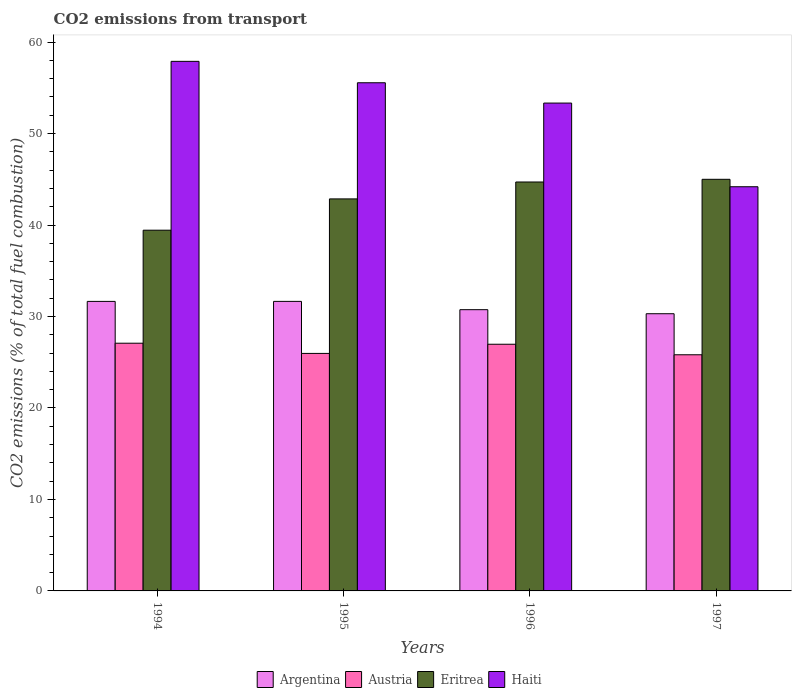Are the number of bars per tick equal to the number of legend labels?
Provide a succinct answer. Yes. Are the number of bars on each tick of the X-axis equal?
Keep it short and to the point. Yes. In how many cases, is the number of bars for a given year not equal to the number of legend labels?
Your answer should be very brief. 0. What is the total CO2 emitted in Haiti in 1997?
Give a very brief answer. 44.19. Across all years, what is the maximum total CO2 emitted in Argentina?
Your answer should be compact. 31.65. Across all years, what is the minimum total CO2 emitted in Argentina?
Make the answer very short. 30.3. In which year was the total CO2 emitted in Haiti maximum?
Offer a terse response. 1994. What is the total total CO2 emitted in Austria in the graph?
Offer a terse response. 105.83. What is the difference between the total CO2 emitted in Eritrea in 1994 and that in 1995?
Provide a short and direct response. -3.42. What is the difference between the total CO2 emitted in Argentina in 1994 and the total CO2 emitted in Eritrea in 1995?
Provide a succinct answer. -11.2. What is the average total CO2 emitted in Eritrea per year?
Offer a terse response. 43. In the year 1996, what is the difference between the total CO2 emitted in Austria and total CO2 emitted in Eritrea?
Your answer should be very brief. -17.74. In how many years, is the total CO2 emitted in Austria greater than 26?
Provide a short and direct response. 2. What is the ratio of the total CO2 emitted in Argentina in 1996 to that in 1997?
Keep it short and to the point. 1.01. Is the difference between the total CO2 emitted in Austria in 1995 and 1997 greater than the difference between the total CO2 emitted in Eritrea in 1995 and 1997?
Provide a short and direct response. Yes. What is the difference between the highest and the second highest total CO2 emitted in Haiti?
Your answer should be very brief. 2.34. What is the difference between the highest and the lowest total CO2 emitted in Austria?
Offer a terse response. 1.26. Is the sum of the total CO2 emitted in Haiti in 1994 and 1995 greater than the maximum total CO2 emitted in Eritrea across all years?
Ensure brevity in your answer.  Yes. What does the 2nd bar from the left in 1995 represents?
Your answer should be compact. Austria. How many bars are there?
Your response must be concise. 16. Are all the bars in the graph horizontal?
Keep it short and to the point. No. How many years are there in the graph?
Offer a terse response. 4. Does the graph contain any zero values?
Provide a succinct answer. No. Does the graph contain grids?
Offer a very short reply. No. Where does the legend appear in the graph?
Provide a short and direct response. Bottom center. How many legend labels are there?
Ensure brevity in your answer.  4. What is the title of the graph?
Your answer should be compact. CO2 emissions from transport. Does "Samoa" appear as one of the legend labels in the graph?
Keep it short and to the point. No. What is the label or title of the Y-axis?
Provide a short and direct response. CO2 emissions (% of total fuel combustion). What is the CO2 emissions (% of total fuel combustion) in Argentina in 1994?
Ensure brevity in your answer.  31.65. What is the CO2 emissions (% of total fuel combustion) of Austria in 1994?
Your answer should be very brief. 27.08. What is the CO2 emissions (% of total fuel combustion) in Eritrea in 1994?
Your response must be concise. 39.44. What is the CO2 emissions (% of total fuel combustion) in Haiti in 1994?
Your response must be concise. 57.89. What is the CO2 emissions (% of total fuel combustion) of Argentina in 1995?
Your answer should be compact. 31.65. What is the CO2 emissions (% of total fuel combustion) in Austria in 1995?
Your response must be concise. 25.96. What is the CO2 emissions (% of total fuel combustion) of Eritrea in 1995?
Make the answer very short. 42.86. What is the CO2 emissions (% of total fuel combustion) in Haiti in 1995?
Give a very brief answer. 55.56. What is the CO2 emissions (% of total fuel combustion) of Argentina in 1996?
Keep it short and to the point. 30.75. What is the CO2 emissions (% of total fuel combustion) in Austria in 1996?
Give a very brief answer. 26.97. What is the CO2 emissions (% of total fuel combustion) of Eritrea in 1996?
Your answer should be very brief. 44.71. What is the CO2 emissions (% of total fuel combustion) in Haiti in 1996?
Provide a succinct answer. 53.33. What is the CO2 emissions (% of total fuel combustion) of Argentina in 1997?
Keep it short and to the point. 30.3. What is the CO2 emissions (% of total fuel combustion) of Austria in 1997?
Make the answer very short. 25.82. What is the CO2 emissions (% of total fuel combustion) in Eritrea in 1997?
Provide a short and direct response. 45. What is the CO2 emissions (% of total fuel combustion) of Haiti in 1997?
Your response must be concise. 44.19. Across all years, what is the maximum CO2 emissions (% of total fuel combustion) in Argentina?
Offer a terse response. 31.65. Across all years, what is the maximum CO2 emissions (% of total fuel combustion) in Austria?
Make the answer very short. 27.08. Across all years, what is the maximum CO2 emissions (% of total fuel combustion) in Haiti?
Give a very brief answer. 57.89. Across all years, what is the minimum CO2 emissions (% of total fuel combustion) in Argentina?
Give a very brief answer. 30.3. Across all years, what is the minimum CO2 emissions (% of total fuel combustion) in Austria?
Make the answer very short. 25.82. Across all years, what is the minimum CO2 emissions (% of total fuel combustion) in Eritrea?
Ensure brevity in your answer.  39.44. Across all years, what is the minimum CO2 emissions (% of total fuel combustion) in Haiti?
Offer a terse response. 44.19. What is the total CO2 emissions (% of total fuel combustion) in Argentina in the graph?
Provide a succinct answer. 124.36. What is the total CO2 emissions (% of total fuel combustion) in Austria in the graph?
Make the answer very short. 105.83. What is the total CO2 emissions (% of total fuel combustion) in Eritrea in the graph?
Keep it short and to the point. 172. What is the total CO2 emissions (% of total fuel combustion) of Haiti in the graph?
Your answer should be very brief. 210.97. What is the difference between the CO2 emissions (% of total fuel combustion) in Argentina in 1994 and that in 1995?
Offer a very short reply. -0. What is the difference between the CO2 emissions (% of total fuel combustion) in Austria in 1994 and that in 1995?
Your answer should be compact. 1.12. What is the difference between the CO2 emissions (% of total fuel combustion) of Eritrea in 1994 and that in 1995?
Offer a very short reply. -3.42. What is the difference between the CO2 emissions (% of total fuel combustion) of Haiti in 1994 and that in 1995?
Make the answer very short. 2.34. What is the difference between the CO2 emissions (% of total fuel combustion) of Argentina in 1994 and that in 1996?
Your answer should be compact. 0.91. What is the difference between the CO2 emissions (% of total fuel combustion) in Austria in 1994 and that in 1996?
Ensure brevity in your answer.  0.11. What is the difference between the CO2 emissions (% of total fuel combustion) in Eritrea in 1994 and that in 1996?
Keep it short and to the point. -5.27. What is the difference between the CO2 emissions (% of total fuel combustion) of Haiti in 1994 and that in 1996?
Your response must be concise. 4.56. What is the difference between the CO2 emissions (% of total fuel combustion) in Argentina in 1994 and that in 1997?
Your answer should be compact. 1.35. What is the difference between the CO2 emissions (% of total fuel combustion) of Austria in 1994 and that in 1997?
Keep it short and to the point. 1.26. What is the difference between the CO2 emissions (% of total fuel combustion) of Eritrea in 1994 and that in 1997?
Make the answer very short. -5.56. What is the difference between the CO2 emissions (% of total fuel combustion) in Haiti in 1994 and that in 1997?
Your answer should be compact. 13.71. What is the difference between the CO2 emissions (% of total fuel combustion) of Argentina in 1995 and that in 1996?
Give a very brief answer. 0.91. What is the difference between the CO2 emissions (% of total fuel combustion) in Austria in 1995 and that in 1996?
Provide a short and direct response. -1. What is the difference between the CO2 emissions (% of total fuel combustion) of Eritrea in 1995 and that in 1996?
Your answer should be compact. -1.85. What is the difference between the CO2 emissions (% of total fuel combustion) in Haiti in 1995 and that in 1996?
Ensure brevity in your answer.  2.22. What is the difference between the CO2 emissions (% of total fuel combustion) of Argentina in 1995 and that in 1997?
Your response must be concise. 1.35. What is the difference between the CO2 emissions (% of total fuel combustion) in Austria in 1995 and that in 1997?
Your answer should be compact. 0.15. What is the difference between the CO2 emissions (% of total fuel combustion) in Eritrea in 1995 and that in 1997?
Give a very brief answer. -2.14. What is the difference between the CO2 emissions (% of total fuel combustion) in Haiti in 1995 and that in 1997?
Your answer should be compact. 11.37. What is the difference between the CO2 emissions (% of total fuel combustion) of Argentina in 1996 and that in 1997?
Give a very brief answer. 0.44. What is the difference between the CO2 emissions (% of total fuel combustion) of Austria in 1996 and that in 1997?
Offer a very short reply. 1.15. What is the difference between the CO2 emissions (% of total fuel combustion) of Eritrea in 1996 and that in 1997?
Your answer should be compact. -0.29. What is the difference between the CO2 emissions (% of total fuel combustion) of Haiti in 1996 and that in 1997?
Offer a terse response. 9.15. What is the difference between the CO2 emissions (% of total fuel combustion) in Argentina in 1994 and the CO2 emissions (% of total fuel combustion) in Austria in 1995?
Ensure brevity in your answer.  5.69. What is the difference between the CO2 emissions (% of total fuel combustion) of Argentina in 1994 and the CO2 emissions (% of total fuel combustion) of Eritrea in 1995?
Provide a succinct answer. -11.2. What is the difference between the CO2 emissions (% of total fuel combustion) of Argentina in 1994 and the CO2 emissions (% of total fuel combustion) of Haiti in 1995?
Your response must be concise. -23.9. What is the difference between the CO2 emissions (% of total fuel combustion) in Austria in 1994 and the CO2 emissions (% of total fuel combustion) in Eritrea in 1995?
Offer a terse response. -15.78. What is the difference between the CO2 emissions (% of total fuel combustion) in Austria in 1994 and the CO2 emissions (% of total fuel combustion) in Haiti in 1995?
Your response must be concise. -28.48. What is the difference between the CO2 emissions (% of total fuel combustion) in Eritrea in 1994 and the CO2 emissions (% of total fuel combustion) in Haiti in 1995?
Offer a very short reply. -16.12. What is the difference between the CO2 emissions (% of total fuel combustion) of Argentina in 1994 and the CO2 emissions (% of total fuel combustion) of Austria in 1996?
Keep it short and to the point. 4.68. What is the difference between the CO2 emissions (% of total fuel combustion) of Argentina in 1994 and the CO2 emissions (% of total fuel combustion) of Eritrea in 1996?
Your response must be concise. -13.05. What is the difference between the CO2 emissions (% of total fuel combustion) of Argentina in 1994 and the CO2 emissions (% of total fuel combustion) of Haiti in 1996?
Ensure brevity in your answer.  -21.68. What is the difference between the CO2 emissions (% of total fuel combustion) in Austria in 1994 and the CO2 emissions (% of total fuel combustion) in Eritrea in 1996?
Your answer should be compact. -17.63. What is the difference between the CO2 emissions (% of total fuel combustion) of Austria in 1994 and the CO2 emissions (% of total fuel combustion) of Haiti in 1996?
Make the answer very short. -26.25. What is the difference between the CO2 emissions (% of total fuel combustion) in Eritrea in 1994 and the CO2 emissions (% of total fuel combustion) in Haiti in 1996?
Your answer should be compact. -13.9. What is the difference between the CO2 emissions (% of total fuel combustion) in Argentina in 1994 and the CO2 emissions (% of total fuel combustion) in Austria in 1997?
Make the answer very short. 5.83. What is the difference between the CO2 emissions (% of total fuel combustion) in Argentina in 1994 and the CO2 emissions (% of total fuel combustion) in Eritrea in 1997?
Offer a terse response. -13.35. What is the difference between the CO2 emissions (% of total fuel combustion) of Argentina in 1994 and the CO2 emissions (% of total fuel combustion) of Haiti in 1997?
Make the answer very short. -12.53. What is the difference between the CO2 emissions (% of total fuel combustion) of Austria in 1994 and the CO2 emissions (% of total fuel combustion) of Eritrea in 1997?
Make the answer very short. -17.92. What is the difference between the CO2 emissions (% of total fuel combustion) of Austria in 1994 and the CO2 emissions (% of total fuel combustion) of Haiti in 1997?
Make the answer very short. -17.11. What is the difference between the CO2 emissions (% of total fuel combustion) of Eritrea in 1994 and the CO2 emissions (% of total fuel combustion) of Haiti in 1997?
Your response must be concise. -4.75. What is the difference between the CO2 emissions (% of total fuel combustion) in Argentina in 1995 and the CO2 emissions (% of total fuel combustion) in Austria in 1996?
Ensure brevity in your answer.  4.68. What is the difference between the CO2 emissions (% of total fuel combustion) of Argentina in 1995 and the CO2 emissions (% of total fuel combustion) of Eritrea in 1996?
Provide a short and direct response. -13.05. What is the difference between the CO2 emissions (% of total fuel combustion) in Argentina in 1995 and the CO2 emissions (% of total fuel combustion) in Haiti in 1996?
Your response must be concise. -21.68. What is the difference between the CO2 emissions (% of total fuel combustion) in Austria in 1995 and the CO2 emissions (% of total fuel combustion) in Eritrea in 1996?
Your answer should be compact. -18.74. What is the difference between the CO2 emissions (% of total fuel combustion) of Austria in 1995 and the CO2 emissions (% of total fuel combustion) of Haiti in 1996?
Your response must be concise. -27.37. What is the difference between the CO2 emissions (% of total fuel combustion) of Eritrea in 1995 and the CO2 emissions (% of total fuel combustion) of Haiti in 1996?
Offer a very short reply. -10.48. What is the difference between the CO2 emissions (% of total fuel combustion) of Argentina in 1995 and the CO2 emissions (% of total fuel combustion) of Austria in 1997?
Your answer should be very brief. 5.84. What is the difference between the CO2 emissions (% of total fuel combustion) of Argentina in 1995 and the CO2 emissions (% of total fuel combustion) of Eritrea in 1997?
Your response must be concise. -13.35. What is the difference between the CO2 emissions (% of total fuel combustion) of Argentina in 1995 and the CO2 emissions (% of total fuel combustion) of Haiti in 1997?
Ensure brevity in your answer.  -12.53. What is the difference between the CO2 emissions (% of total fuel combustion) in Austria in 1995 and the CO2 emissions (% of total fuel combustion) in Eritrea in 1997?
Provide a succinct answer. -19.04. What is the difference between the CO2 emissions (% of total fuel combustion) in Austria in 1995 and the CO2 emissions (% of total fuel combustion) in Haiti in 1997?
Provide a short and direct response. -18.22. What is the difference between the CO2 emissions (% of total fuel combustion) of Eritrea in 1995 and the CO2 emissions (% of total fuel combustion) of Haiti in 1997?
Provide a succinct answer. -1.33. What is the difference between the CO2 emissions (% of total fuel combustion) in Argentina in 1996 and the CO2 emissions (% of total fuel combustion) in Austria in 1997?
Keep it short and to the point. 4.93. What is the difference between the CO2 emissions (% of total fuel combustion) in Argentina in 1996 and the CO2 emissions (% of total fuel combustion) in Eritrea in 1997?
Make the answer very short. -14.25. What is the difference between the CO2 emissions (% of total fuel combustion) in Argentina in 1996 and the CO2 emissions (% of total fuel combustion) in Haiti in 1997?
Offer a very short reply. -13.44. What is the difference between the CO2 emissions (% of total fuel combustion) of Austria in 1996 and the CO2 emissions (% of total fuel combustion) of Eritrea in 1997?
Provide a short and direct response. -18.03. What is the difference between the CO2 emissions (% of total fuel combustion) in Austria in 1996 and the CO2 emissions (% of total fuel combustion) in Haiti in 1997?
Ensure brevity in your answer.  -17.22. What is the difference between the CO2 emissions (% of total fuel combustion) of Eritrea in 1996 and the CO2 emissions (% of total fuel combustion) of Haiti in 1997?
Make the answer very short. 0.52. What is the average CO2 emissions (% of total fuel combustion) in Argentina per year?
Your answer should be compact. 31.09. What is the average CO2 emissions (% of total fuel combustion) of Austria per year?
Your response must be concise. 26.46. What is the average CO2 emissions (% of total fuel combustion) in Eritrea per year?
Give a very brief answer. 43. What is the average CO2 emissions (% of total fuel combustion) of Haiti per year?
Make the answer very short. 52.74. In the year 1994, what is the difference between the CO2 emissions (% of total fuel combustion) of Argentina and CO2 emissions (% of total fuel combustion) of Austria?
Your response must be concise. 4.57. In the year 1994, what is the difference between the CO2 emissions (% of total fuel combustion) of Argentina and CO2 emissions (% of total fuel combustion) of Eritrea?
Provide a succinct answer. -7.78. In the year 1994, what is the difference between the CO2 emissions (% of total fuel combustion) of Argentina and CO2 emissions (% of total fuel combustion) of Haiti?
Your answer should be very brief. -26.24. In the year 1994, what is the difference between the CO2 emissions (% of total fuel combustion) in Austria and CO2 emissions (% of total fuel combustion) in Eritrea?
Make the answer very short. -12.36. In the year 1994, what is the difference between the CO2 emissions (% of total fuel combustion) of Austria and CO2 emissions (% of total fuel combustion) of Haiti?
Your answer should be compact. -30.81. In the year 1994, what is the difference between the CO2 emissions (% of total fuel combustion) in Eritrea and CO2 emissions (% of total fuel combustion) in Haiti?
Your response must be concise. -18.46. In the year 1995, what is the difference between the CO2 emissions (% of total fuel combustion) of Argentina and CO2 emissions (% of total fuel combustion) of Austria?
Provide a succinct answer. 5.69. In the year 1995, what is the difference between the CO2 emissions (% of total fuel combustion) of Argentina and CO2 emissions (% of total fuel combustion) of Eritrea?
Keep it short and to the point. -11.2. In the year 1995, what is the difference between the CO2 emissions (% of total fuel combustion) of Argentina and CO2 emissions (% of total fuel combustion) of Haiti?
Provide a succinct answer. -23.9. In the year 1995, what is the difference between the CO2 emissions (% of total fuel combustion) of Austria and CO2 emissions (% of total fuel combustion) of Eritrea?
Make the answer very short. -16.89. In the year 1995, what is the difference between the CO2 emissions (% of total fuel combustion) in Austria and CO2 emissions (% of total fuel combustion) in Haiti?
Make the answer very short. -29.59. In the year 1995, what is the difference between the CO2 emissions (% of total fuel combustion) of Eritrea and CO2 emissions (% of total fuel combustion) of Haiti?
Your answer should be very brief. -12.7. In the year 1996, what is the difference between the CO2 emissions (% of total fuel combustion) in Argentina and CO2 emissions (% of total fuel combustion) in Austria?
Offer a terse response. 3.78. In the year 1996, what is the difference between the CO2 emissions (% of total fuel combustion) of Argentina and CO2 emissions (% of total fuel combustion) of Eritrea?
Your answer should be compact. -13.96. In the year 1996, what is the difference between the CO2 emissions (% of total fuel combustion) in Argentina and CO2 emissions (% of total fuel combustion) in Haiti?
Keep it short and to the point. -22.59. In the year 1996, what is the difference between the CO2 emissions (% of total fuel combustion) in Austria and CO2 emissions (% of total fuel combustion) in Eritrea?
Offer a terse response. -17.74. In the year 1996, what is the difference between the CO2 emissions (% of total fuel combustion) in Austria and CO2 emissions (% of total fuel combustion) in Haiti?
Make the answer very short. -26.36. In the year 1996, what is the difference between the CO2 emissions (% of total fuel combustion) in Eritrea and CO2 emissions (% of total fuel combustion) in Haiti?
Ensure brevity in your answer.  -8.63. In the year 1997, what is the difference between the CO2 emissions (% of total fuel combustion) of Argentina and CO2 emissions (% of total fuel combustion) of Austria?
Offer a very short reply. 4.49. In the year 1997, what is the difference between the CO2 emissions (% of total fuel combustion) in Argentina and CO2 emissions (% of total fuel combustion) in Eritrea?
Provide a short and direct response. -14.7. In the year 1997, what is the difference between the CO2 emissions (% of total fuel combustion) of Argentina and CO2 emissions (% of total fuel combustion) of Haiti?
Offer a very short reply. -13.88. In the year 1997, what is the difference between the CO2 emissions (% of total fuel combustion) of Austria and CO2 emissions (% of total fuel combustion) of Eritrea?
Your answer should be very brief. -19.18. In the year 1997, what is the difference between the CO2 emissions (% of total fuel combustion) of Austria and CO2 emissions (% of total fuel combustion) of Haiti?
Provide a short and direct response. -18.37. In the year 1997, what is the difference between the CO2 emissions (% of total fuel combustion) in Eritrea and CO2 emissions (% of total fuel combustion) in Haiti?
Make the answer very short. 0.81. What is the ratio of the CO2 emissions (% of total fuel combustion) of Austria in 1994 to that in 1995?
Keep it short and to the point. 1.04. What is the ratio of the CO2 emissions (% of total fuel combustion) in Eritrea in 1994 to that in 1995?
Offer a very short reply. 0.92. What is the ratio of the CO2 emissions (% of total fuel combustion) of Haiti in 1994 to that in 1995?
Your answer should be very brief. 1.04. What is the ratio of the CO2 emissions (% of total fuel combustion) in Argentina in 1994 to that in 1996?
Provide a short and direct response. 1.03. What is the ratio of the CO2 emissions (% of total fuel combustion) of Eritrea in 1994 to that in 1996?
Offer a terse response. 0.88. What is the ratio of the CO2 emissions (% of total fuel combustion) in Haiti in 1994 to that in 1996?
Give a very brief answer. 1.09. What is the ratio of the CO2 emissions (% of total fuel combustion) of Argentina in 1994 to that in 1997?
Provide a succinct answer. 1.04. What is the ratio of the CO2 emissions (% of total fuel combustion) in Austria in 1994 to that in 1997?
Your answer should be very brief. 1.05. What is the ratio of the CO2 emissions (% of total fuel combustion) of Eritrea in 1994 to that in 1997?
Keep it short and to the point. 0.88. What is the ratio of the CO2 emissions (% of total fuel combustion) of Haiti in 1994 to that in 1997?
Keep it short and to the point. 1.31. What is the ratio of the CO2 emissions (% of total fuel combustion) of Argentina in 1995 to that in 1996?
Offer a very short reply. 1.03. What is the ratio of the CO2 emissions (% of total fuel combustion) of Austria in 1995 to that in 1996?
Offer a very short reply. 0.96. What is the ratio of the CO2 emissions (% of total fuel combustion) in Eritrea in 1995 to that in 1996?
Your answer should be very brief. 0.96. What is the ratio of the CO2 emissions (% of total fuel combustion) in Haiti in 1995 to that in 1996?
Give a very brief answer. 1.04. What is the ratio of the CO2 emissions (% of total fuel combustion) of Argentina in 1995 to that in 1997?
Provide a succinct answer. 1.04. What is the ratio of the CO2 emissions (% of total fuel combustion) of Eritrea in 1995 to that in 1997?
Your answer should be very brief. 0.95. What is the ratio of the CO2 emissions (% of total fuel combustion) of Haiti in 1995 to that in 1997?
Provide a short and direct response. 1.26. What is the ratio of the CO2 emissions (% of total fuel combustion) of Argentina in 1996 to that in 1997?
Make the answer very short. 1.01. What is the ratio of the CO2 emissions (% of total fuel combustion) of Austria in 1996 to that in 1997?
Keep it short and to the point. 1.04. What is the ratio of the CO2 emissions (% of total fuel combustion) in Eritrea in 1996 to that in 1997?
Provide a succinct answer. 0.99. What is the ratio of the CO2 emissions (% of total fuel combustion) in Haiti in 1996 to that in 1997?
Your answer should be very brief. 1.21. What is the difference between the highest and the second highest CO2 emissions (% of total fuel combustion) of Argentina?
Keep it short and to the point. 0. What is the difference between the highest and the second highest CO2 emissions (% of total fuel combustion) of Austria?
Make the answer very short. 0.11. What is the difference between the highest and the second highest CO2 emissions (% of total fuel combustion) of Eritrea?
Offer a very short reply. 0.29. What is the difference between the highest and the second highest CO2 emissions (% of total fuel combustion) in Haiti?
Give a very brief answer. 2.34. What is the difference between the highest and the lowest CO2 emissions (% of total fuel combustion) of Argentina?
Offer a terse response. 1.35. What is the difference between the highest and the lowest CO2 emissions (% of total fuel combustion) in Austria?
Provide a succinct answer. 1.26. What is the difference between the highest and the lowest CO2 emissions (% of total fuel combustion) of Eritrea?
Your response must be concise. 5.56. What is the difference between the highest and the lowest CO2 emissions (% of total fuel combustion) of Haiti?
Make the answer very short. 13.71. 